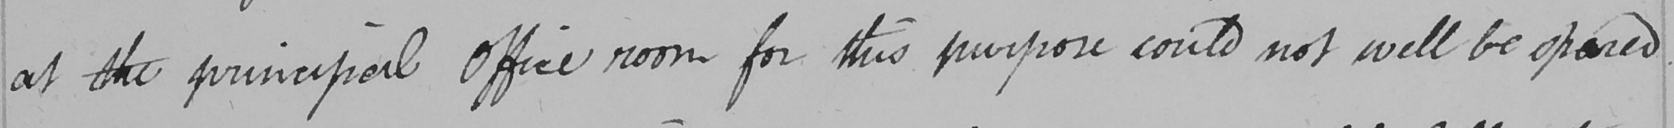Transcribe the text shown in this historical manuscript line. at the principal Office room for this purpose could not well be spared 